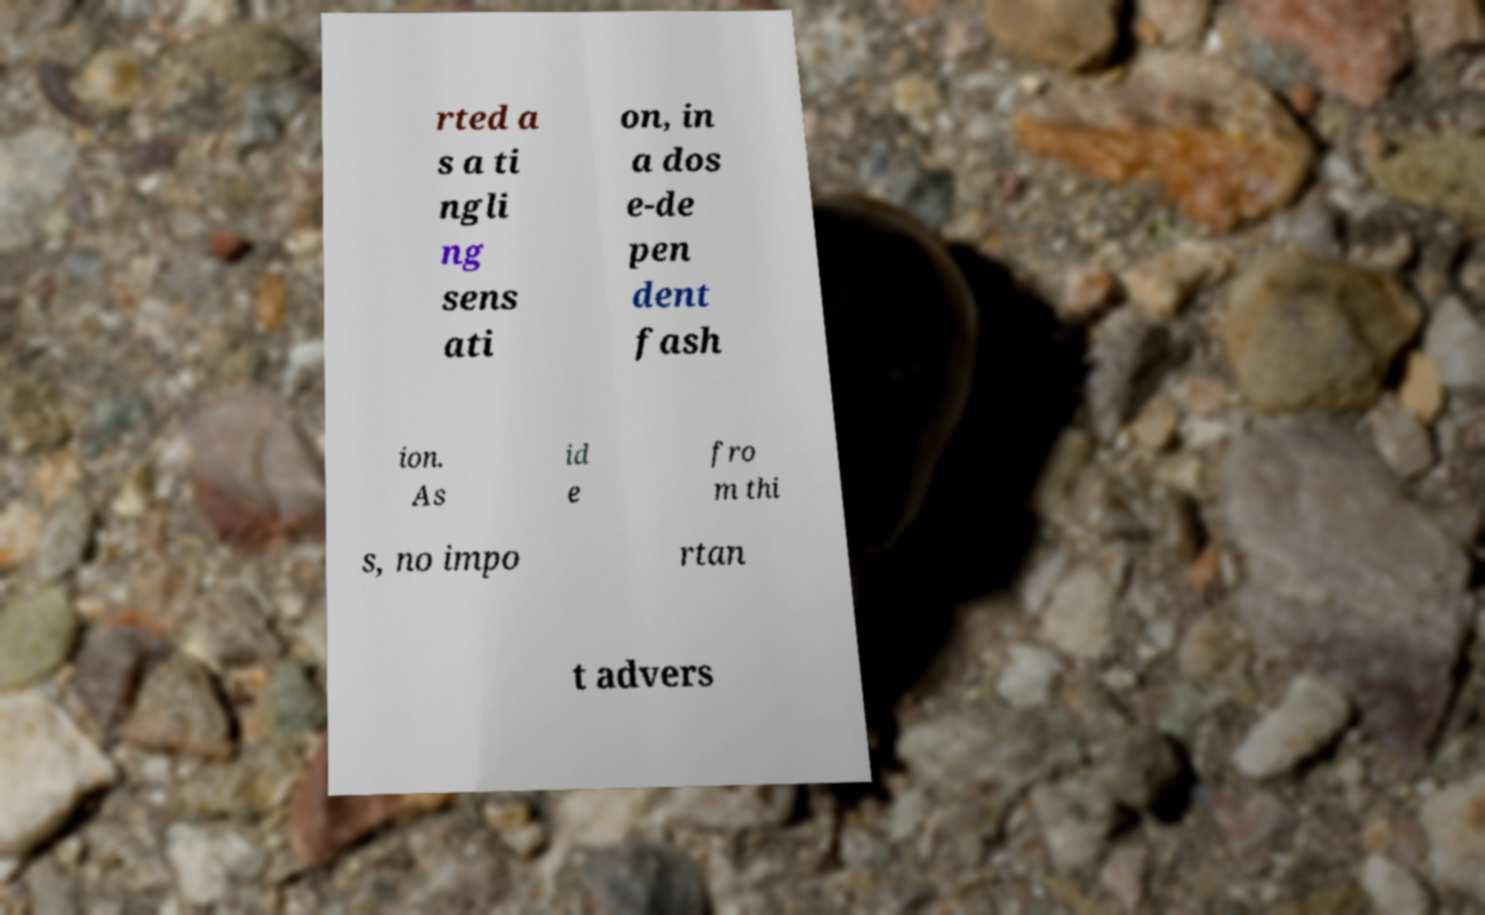What messages or text are displayed in this image? I need them in a readable, typed format. rted a s a ti ngli ng sens ati on, in a dos e-de pen dent fash ion. As id e fro m thi s, no impo rtan t advers 